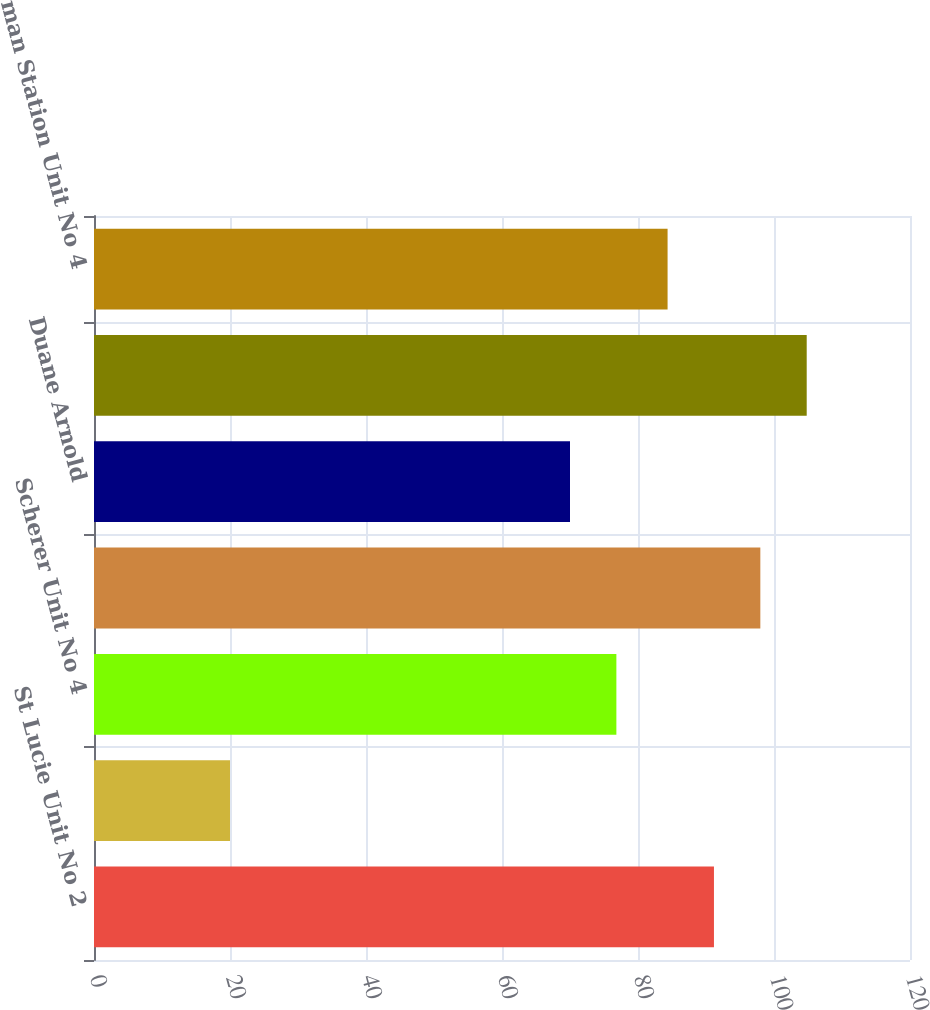<chart> <loc_0><loc_0><loc_500><loc_500><bar_chart><fcel>St Lucie Unit No 2<fcel>St Johns River Power Park<fcel>Scherer Unit No 4<fcel>Transmission substation assets<fcel>Duane Arnold<fcel>Seabrook<fcel>Wyman Station Unit No 4<nl><fcel>91.17<fcel>20<fcel>76.82<fcel>97.99<fcel>70<fcel>104.81<fcel>84.35<nl></chart> 